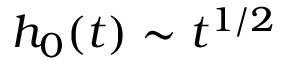<formula> <loc_0><loc_0><loc_500><loc_500>h _ { 0 } ( t ) \sim t ^ { 1 / 2 }</formula> 